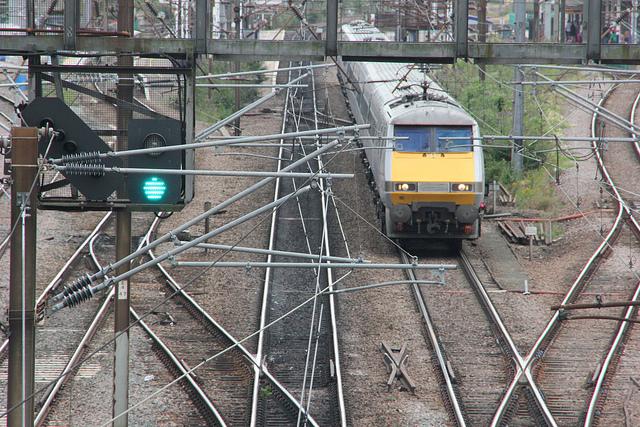Is this train moving swiftly?
Give a very brief answer. No. What color is the light on the left?
Give a very brief answer. Green. What color is the signal light?
Be succinct. Green. Is the train going around a curve?
Answer briefly. No. What powers this train?
Be succinct. Electricity. 